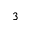Convert formula to latex. <formula><loc_0><loc_0><loc_500><loc_500>_ { 3 }</formula> 